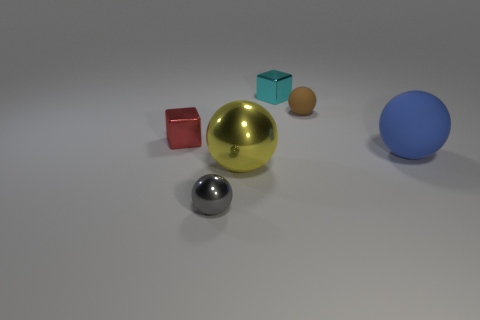Add 2 large yellow shiny spheres. How many objects exist? 8 Subtract all cubes. How many objects are left? 4 Add 2 large brown cylinders. How many large brown cylinders exist? 2 Subtract 0 gray blocks. How many objects are left? 6 Subtract all red metal blocks. Subtract all small rubber objects. How many objects are left? 4 Add 4 brown rubber spheres. How many brown rubber spheres are left? 5 